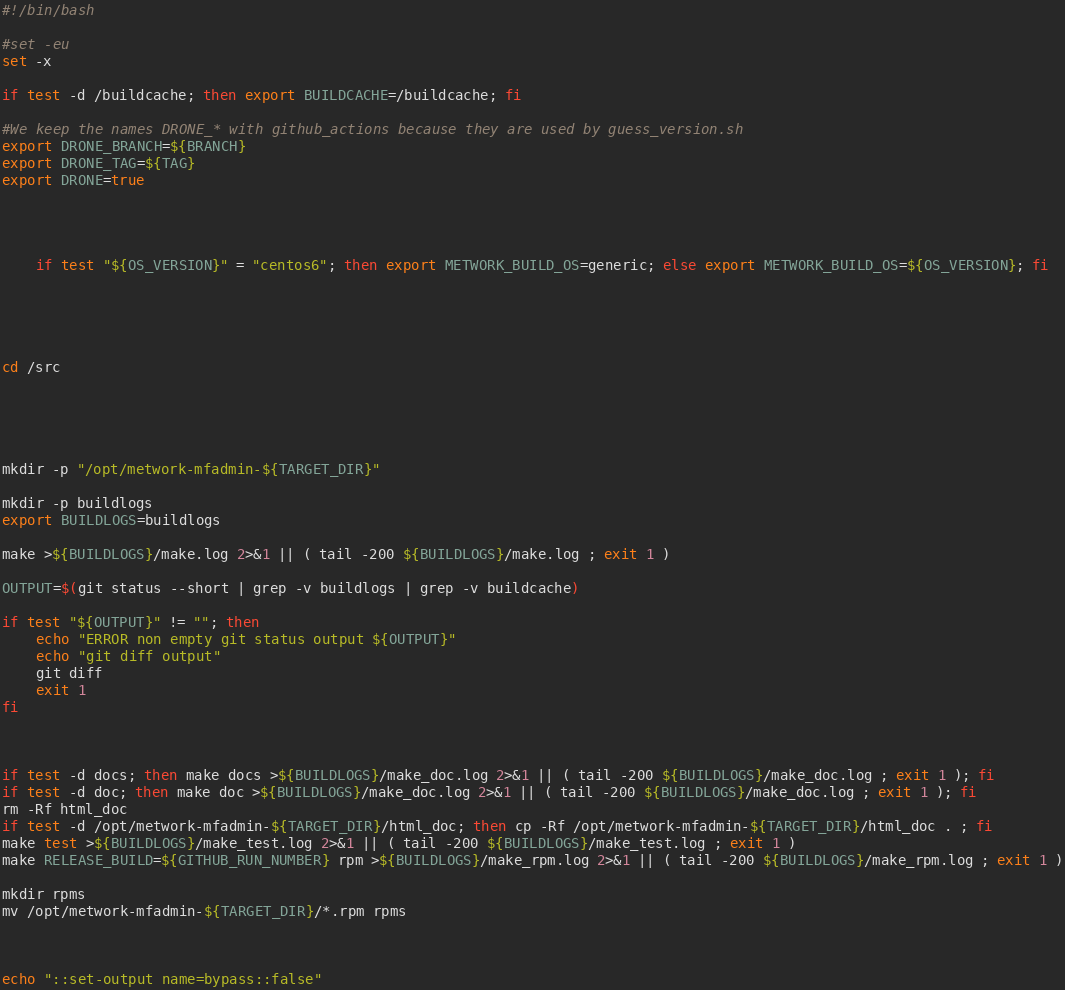<code> <loc_0><loc_0><loc_500><loc_500><_Bash_>#!/bin/bash

#set -eu
set -x

if test -d /buildcache; then export BUILDCACHE=/buildcache; fi

#We keep the names DRONE_* with github_actions because they are used by guess_version.sh
export DRONE_BRANCH=${BRANCH}
export DRONE_TAG=${TAG}
export DRONE=true




    if test "${OS_VERSION}" = "centos6"; then export METWORK_BUILD_OS=generic; else export METWORK_BUILD_OS=${OS_VERSION}; fi





cd /src





mkdir -p "/opt/metwork-mfadmin-${TARGET_DIR}"

mkdir -p buildlogs
export BUILDLOGS=buildlogs

make >${BUILDLOGS}/make.log 2>&1 || ( tail -200 ${BUILDLOGS}/make.log ; exit 1 )

OUTPUT=$(git status --short | grep -v buildlogs | grep -v buildcache)

if test "${OUTPUT}" != ""; then
    echo "ERROR non empty git status output ${OUTPUT}"
    echo "git diff output"
    git diff
    exit 1
fi

 

if test -d docs; then make docs >${BUILDLOGS}/make_doc.log 2>&1 || ( tail -200 ${BUILDLOGS}/make_doc.log ; exit 1 ); fi
if test -d doc; then make doc >${BUILDLOGS}/make_doc.log 2>&1 || ( tail -200 ${BUILDLOGS}/make_doc.log ; exit 1 ); fi
rm -Rf html_doc
if test -d /opt/metwork-mfadmin-${TARGET_DIR}/html_doc; then cp -Rf /opt/metwork-mfadmin-${TARGET_DIR}/html_doc . ; fi
make test >${BUILDLOGS}/make_test.log 2>&1 || ( tail -200 ${BUILDLOGS}/make_test.log ; exit 1 )
make RELEASE_BUILD=${GITHUB_RUN_NUMBER} rpm >${BUILDLOGS}/make_rpm.log 2>&1 || ( tail -200 ${BUILDLOGS}/make_rpm.log ; exit 1 )

mkdir rpms
mv /opt/metwork-mfadmin-${TARGET_DIR}/*.rpm rpms

 

echo "::set-output name=bypass::false"
</code> 